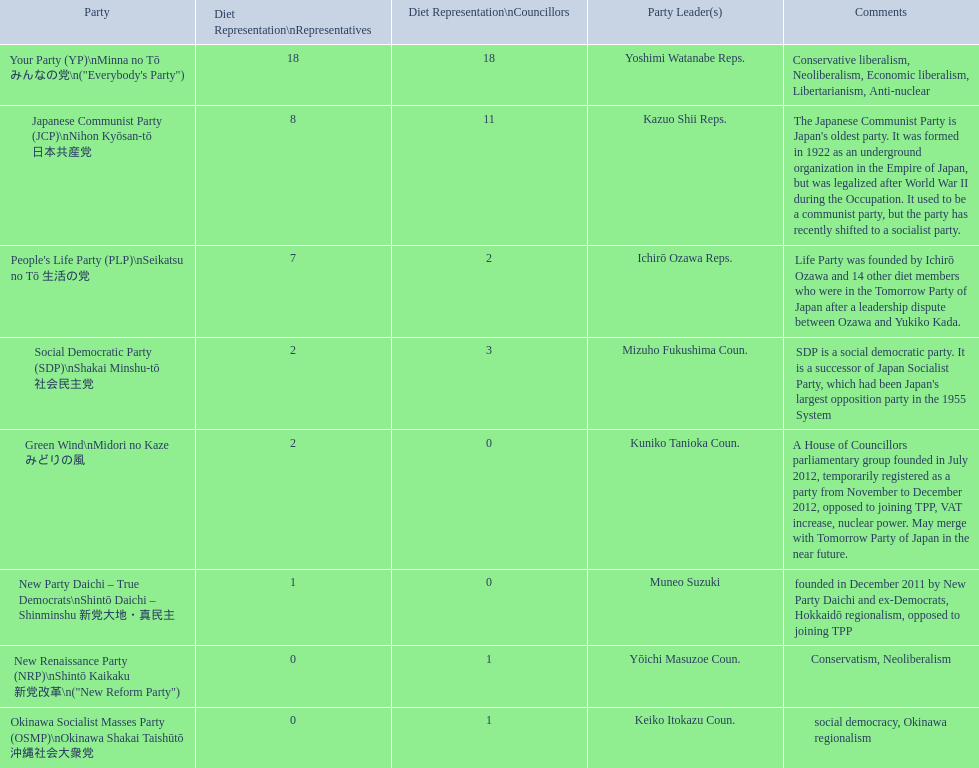People's life party has at most, how many party leaders? 1. Can you parse all the data within this table? {'header': ['Party', 'Diet Representation\\nRepresentatives', 'Diet Representation\\nCouncillors', 'Party Leader(s)', 'Comments'], 'rows': [['Your Party (YP)\\nMinna no Tō みんなの党\\n("Everybody\'s Party")', '18', '18', 'Yoshimi Watanabe Reps.', 'Conservative liberalism, Neoliberalism, Economic liberalism, Libertarianism, Anti-nuclear'], ['Japanese Communist Party (JCP)\\nNihon Kyōsan-tō 日本共産党', '8', '11', 'Kazuo Shii Reps.', "The Japanese Communist Party is Japan's oldest party. It was formed in 1922 as an underground organization in the Empire of Japan, but was legalized after World War II during the Occupation. It used to be a communist party, but the party has recently shifted to a socialist party."], ["People's Life Party (PLP)\\nSeikatsu no Tō 生活の党", '7', '2', 'Ichirō Ozawa Reps.', 'Life Party was founded by Ichirō Ozawa and 14 other diet members who were in the Tomorrow Party of Japan after a leadership dispute between Ozawa and Yukiko Kada.'], ['Social Democratic Party (SDP)\\nShakai Minshu-tō 社会民主党', '2', '3', 'Mizuho Fukushima Coun.', "SDP is a social democratic party. It is a successor of Japan Socialist Party, which had been Japan's largest opposition party in the 1955 System"], ['Green Wind\\nMidori no Kaze みどりの風', '2', '0', 'Kuniko Tanioka Coun.', 'A House of Councillors parliamentary group founded in July 2012, temporarily registered as a party from November to December 2012, opposed to joining TPP, VAT increase, nuclear power. May merge with Tomorrow Party of Japan in the near future.'], ['New Party Daichi – True Democrats\\nShintō Daichi – Shinminshu 新党大地・真民主', '1', '0', 'Muneo Suzuki', 'founded in December 2011 by New Party Daichi and ex-Democrats, Hokkaidō regionalism, opposed to joining TPP'], ['New Renaissance Party (NRP)\\nShintō Kaikaku 新党改革\\n("New Reform Party")', '0', '1', 'Yōichi Masuzoe Coun.', 'Conservatism, Neoliberalism'], ['Okinawa Socialist Masses Party (OSMP)\\nOkinawa Shakai Taishūtō 沖縄社会大衆党', '0', '1', 'Keiko Itokazu Coun.', 'social democracy, Okinawa regionalism']]} 